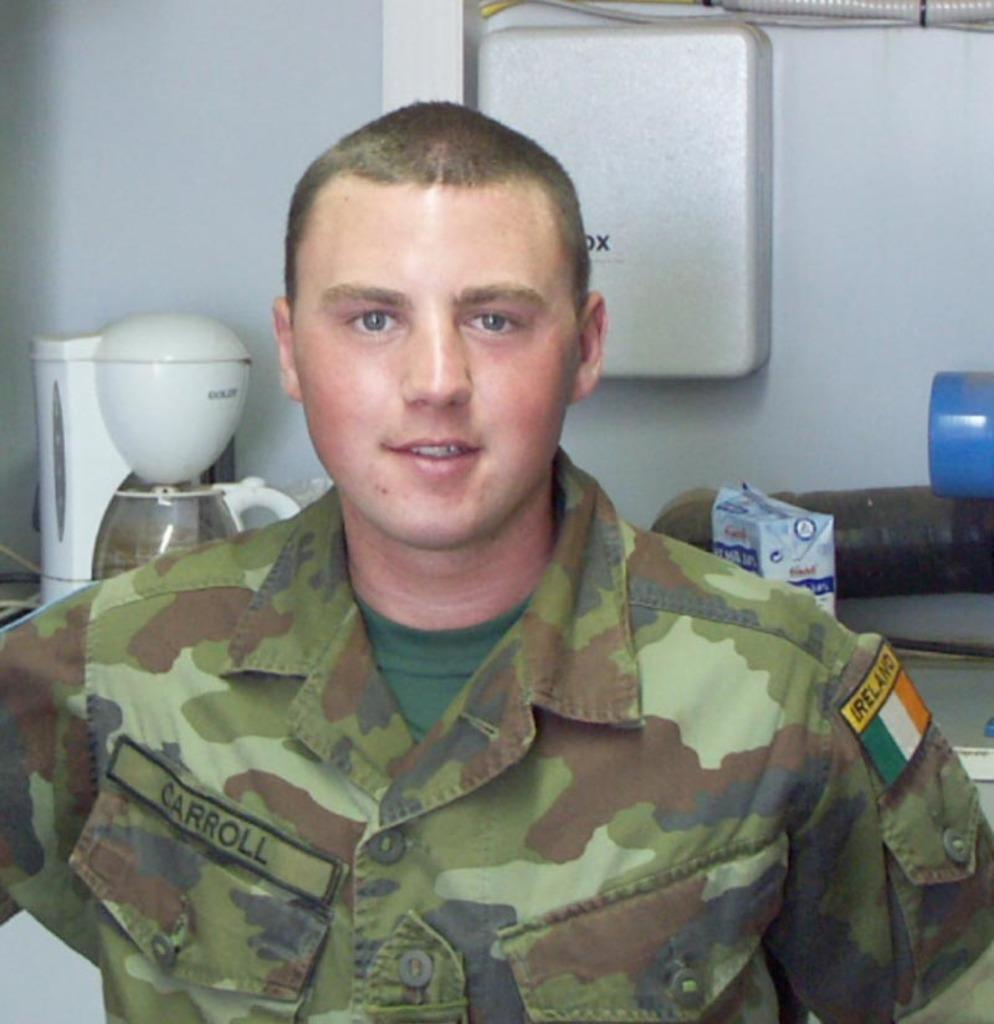<image>
Give a short and clear explanation of the subsequent image. Soldier Carroll stands in a room with a coffee maker behind him. 